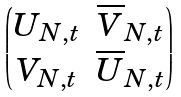<formula> <loc_0><loc_0><loc_500><loc_500>\begin{pmatrix} U _ { N , t } & \overline { V } _ { N , t } \\ V _ { N , t } & \overline { U } _ { N , t } \end{pmatrix}</formula> 